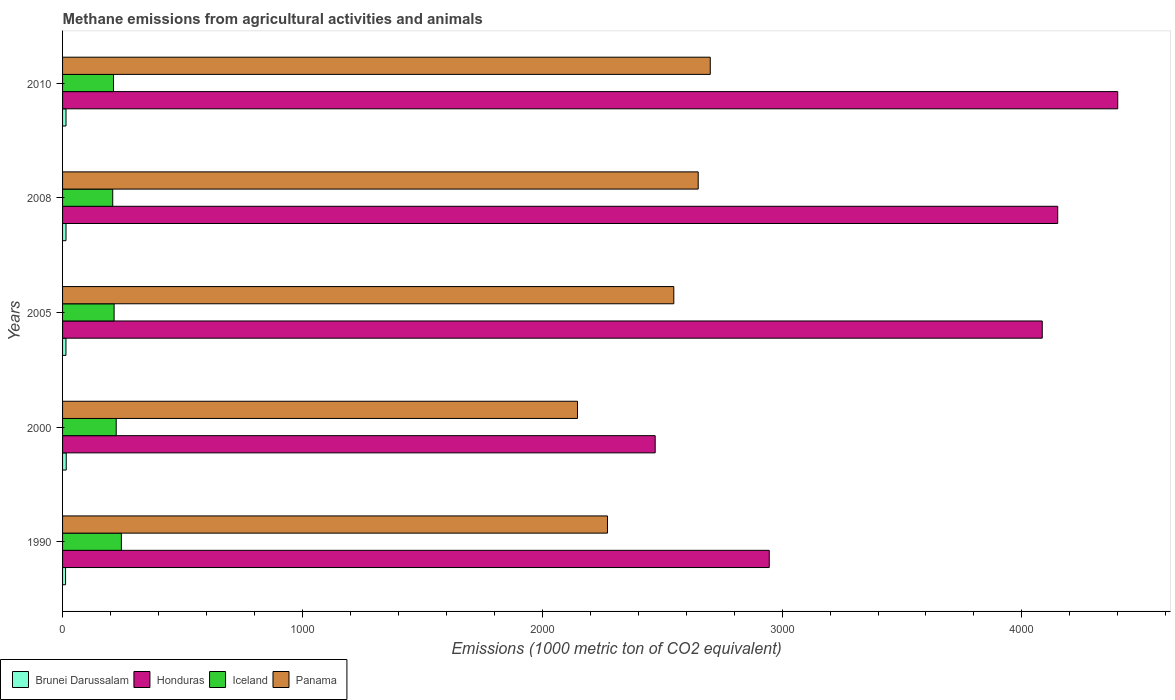How many groups of bars are there?
Ensure brevity in your answer.  5. Are the number of bars per tick equal to the number of legend labels?
Make the answer very short. Yes. Are the number of bars on each tick of the Y-axis equal?
Offer a terse response. Yes. In how many cases, is the number of bars for a given year not equal to the number of legend labels?
Keep it short and to the point. 0. What is the amount of methane emitted in Iceland in 2005?
Ensure brevity in your answer.  214.9. Across all years, what is the maximum amount of methane emitted in Brunei Darussalam?
Ensure brevity in your answer.  15.3. Across all years, what is the minimum amount of methane emitted in Brunei Darussalam?
Ensure brevity in your answer.  12.5. In which year was the amount of methane emitted in Panama maximum?
Offer a terse response. 2010. In which year was the amount of methane emitted in Brunei Darussalam minimum?
Provide a succinct answer. 1990. What is the total amount of methane emitted in Iceland in the graph?
Your answer should be compact. 1105.5. What is the difference between the amount of methane emitted in Iceland in 2008 and that in 2010?
Your answer should be compact. -3.2. What is the difference between the amount of methane emitted in Brunei Darussalam in 1990 and the amount of methane emitted in Iceland in 2005?
Give a very brief answer. -202.4. What is the average amount of methane emitted in Panama per year?
Your answer should be compact. 2463.68. In the year 2008, what is the difference between the amount of methane emitted in Panama and amount of methane emitted in Brunei Darussalam?
Ensure brevity in your answer.  2636. What is the ratio of the amount of methane emitted in Iceland in 2000 to that in 2008?
Your answer should be very brief. 1.07. What is the difference between the highest and the second highest amount of methane emitted in Panama?
Give a very brief answer. 50.3. What is the difference between the highest and the lowest amount of methane emitted in Honduras?
Provide a short and direct response. 1928.6. Is the sum of the amount of methane emitted in Iceland in 2005 and 2008 greater than the maximum amount of methane emitted in Honduras across all years?
Provide a short and direct response. No. What does the 1st bar from the bottom in 2000 represents?
Offer a very short reply. Brunei Darussalam. Is it the case that in every year, the sum of the amount of methane emitted in Panama and amount of methane emitted in Iceland is greater than the amount of methane emitted in Honduras?
Offer a terse response. No. Are all the bars in the graph horizontal?
Ensure brevity in your answer.  Yes. How many years are there in the graph?
Make the answer very short. 5. What is the difference between two consecutive major ticks on the X-axis?
Provide a succinct answer. 1000. Are the values on the major ticks of X-axis written in scientific E-notation?
Your answer should be very brief. No. Does the graph contain any zero values?
Your answer should be compact. No. What is the title of the graph?
Ensure brevity in your answer.  Methane emissions from agricultural activities and animals. Does "Mauritius" appear as one of the legend labels in the graph?
Provide a succinct answer. No. What is the label or title of the X-axis?
Give a very brief answer. Emissions (1000 metric ton of CO2 equivalent). What is the Emissions (1000 metric ton of CO2 equivalent) of Brunei Darussalam in 1990?
Your response must be concise. 12.5. What is the Emissions (1000 metric ton of CO2 equivalent) in Honduras in 1990?
Provide a succinct answer. 2946.5. What is the Emissions (1000 metric ton of CO2 equivalent) of Iceland in 1990?
Your answer should be very brief. 245.3. What is the Emissions (1000 metric ton of CO2 equivalent) of Panama in 1990?
Keep it short and to the point. 2272. What is the Emissions (1000 metric ton of CO2 equivalent) of Honduras in 2000?
Keep it short and to the point. 2470.9. What is the Emissions (1000 metric ton of CO2 equivalent) of Iceland in 2000?
Provide a short and direct response. 223.7. What is the Emissions (1000 metric ton of CO2 equivalent) in Panama in 2000?
Offer a very short reply. 2147. What is the Emissions (1000 metric ton of CO2 equivalent) of Honduras in 2005?
Provide a succinct answer. 4084.8. What is the Emissions (1000 metric ton of CO2 equivalent) of Iceland in 2005?
Offer a very short reply. 214.9. What is the Emissions (1000 metric ton of CO2 equivalent) in Panama in 2005?
Ensure brevity in your answer.  2548.5. What is the Emissions (1000 metric ton of CO2 equivalent) of Honduras in 2008?
Provide a short and direct response. 4149.3. What is the Emissions (1000 metric ton of CO2 equivalent) of Iceland in 2008?
Provide a short and direct response. 209.2. What is the Emissions (1000 metric ton of CO2 equivalent) in Panama in 2008?
Keep it short and to the point. 2650.3. What is the Emissions (1000 metric ton of CO2 equivalent) of Honduras in 2010?
Keep it short and to the point. 4399.5. What is the Emissions (1000 metric ton of CO2 equivalent) in Iceland in 2010?
Provide a short and direct response. 212.4. What is the Emissions (1000 metric ton of CO2 equivalent) of Panama in 2010?
Make the answer very short. 2700.6. Across all years, what is the maximum Emissions (1000 metric ton of CO2 equivalent) of Honduras?
Offer a very short reply. 4399.5. Across all years, what is the maximum Emissions (1000 metric ton of CO2 equivalent) of Iceland?
Offer a terse response. 245.3. Across all years, what is the maximum Emissions (1000 metric ton of CO2 equivalent) in Panama?
Your answer should be very brief. 2700.6. Across all years, what is the minimum Emissions (1000 metric ton of CO2 equivalent) of Honduras?
Keep it short and to the point. 2470.9. Across all years, what is the minimum Emissions (1000 metric ton of CO2 equivalent) in Iceland?
Your answer should be very brief. 209.2. Across all years, what is the minimum Emissions (1000 metric ton of CO2 equivalent) in Panama?
Keep it short and to the point. 2147. What is the total Emissions (1000 metric ton of CO2 equivalent) in Brunei Darussalam in the graph?
Offer a very short reply. 70.6. What is the total Emissions (1000 metric ton of CO2 equivalent) in Honduras in the graph?
Provide a succinct answer. 1.81e+04. What is the total Emissions (1000 metric ton of CO2 equivalent) of Iceland in the graph?
Offer a terse response. 1105.5. What is the total Emissions (1000 metric ton of CO2 equivalent) in Panama in the graph?
Your answer should be compact. 1.23e+04. What is the difference between the Emissions (1000 metric ton of CO2 equivalent) in Brunei Darussalam in 1990 and that in 2000?
Your response must be concise. -2.8. What is the difference between the Emissions (1000 metric ton of CO2 equivalent) of Honduras in 1990 and that in 2000?
Your answer should be compact. 475.6. What is the difference between the Emissions (1000 metric ton of CO2 equivalent) of Iceland in 1990 and that in 2000?
Make the answer very short. 21.6. What is the difference between the Emissions (1000 metric ton of CO2 equivalent) of Panama in 1990 and that in 2000?
Keep it short and to the point. 125. What is the difference between the Emissions (1000 metric ton of CO2 equivalent) of Honduras in 1990 and that in 2005?
Provide a short and direct response. -1138.3. What is the difference between the Emissions (1000 metric ton of CO2 equivalent) in Iceland in 1990 and that in 2005?
Your response must be concise. 30.4. What is the difference between the Emissions (1000 metric ton of CO2 equivalent) of Panama in 1990 and that in 2005?
Give a very brief answer. -276.5. What is the difference between the Emissions (1000 metric ton of CO2 equivalent) of Brunei Darussalam in 1990 and that in 2008?
Offer a very short reply. -1.8. What is the difference between the Emissions (1000 metric ton of CO2 equivalent) in Honduras in 1990 and that in 2008?
Provide a succinct answer. -1202.8. What is the difference between the Emissions (1000 metric ton of CO2 equivalent) in Iceland in 1990 and that in 2008?
Offer a very short reply. 36.1. What is the difference between the Emissions (1000 metric ton of CO2 equivalent) in Panama in 1990 and that in 2008?
Provide a succinct answer. -378.3. What is the difference between the Emissions (1000 metric ton of CO2 equivalent) in Brunei Darussalam in 1990 and that in 2010?
Provide a succinct answer. -1.9. What is the difference between the Emissions (1000 metric ton of CO2 equivalent) of Honduras in 1990 and that in 2010?
Offer a terse response. -1453. What is the difference between the Emissions (1000 metric ton of CO2 equivalent) in Iceland in 1990 and that in 2010?
Your answer should be compact. 32.9. What is the difference between the Emissions (1000 metric ton of CO2 equivalent) in Panama in 1990 and that in 2010?
Make the answer very short. -428.6. What is the difference between the Emissions (1000 metric ton of CO2 equivalent) in Brunei Darussalam in 2000 and that in 2005?
Your answer should be very brief. 1.2. What is the difference between the Emissions (1000 metric ton of CO2 equivalent) in Honduras in 2000 and that in 2005?
Your response must be concise. -1613.9. What is the difference between the Emissions (1000 metric ton of CO2 equivalent) in Iceland in 2000 and that in 2005?
Your answer should be compact. 8.8. What is the difference between the Emissions (1000 metric ton of CO2 equivalent) of Panama in 2000 and that in 2005?
Your response must be concise. -401.5. What is the difference between the Emissions (1000 metric ton of CO2 equivalent) in Honduras in 2000 and that in 2008?
Keep it short and to the point. -1678.4. What is the difference between the Emissions (1000 metric ton of CO2 equivalent) of Iceland in 2000 and that in 2008?
Make the answer very short. 14.5. What is the difference between the Emissions (1000 metric ton of CO2 equivalent) of Panama in 2000 and that in 2008?
Provide a succinct answer. -503.3. What is the difference between the Emissions (1000 metric ton of CO2 equivalent) in Brunei Darussalam in 2000 and that in 2010?
Offer a terse response. 0.9. What is the difference between the Emissions (1000 metric ton of CO2 equivalent) in Honduras in 2000 and that in 2010?
Your response must be concise. -1928.6. What is the difference between the Emissions (1000 metric ton of CO2 equivalent) in Panama in 2000 and that in 2010?
Make the answer very short. -553.6. What is the difference between the Emissions (1000 metric ton of CO2 equivalent) in Honduras in 2005 and that in 2008?
Your answer should be very brief. -64.5. What is the difference between the Emissions (1000 metric ton of CO2 equivalent) in Panama in 2005 and that in 2008?
Ensure brevity in your answer.  -101.8. What is the difference between the Emissions (1000 metric ton of CO2 equivalent) in Brunei Darussalam in 2005 and that in 2010?
Your response must be concise. -0.3. What is the difference between the Emissions (1000 metric ton of CO2 equivalent) in Honduras in 2005 and that in 2010?
Provide a succinct answer. -314.7. What is the difference between the Emissions (1000 metric ton of CO2 equivalent) in Iceland in 2005 and that in 2010?
Your answer should be very brief. 2.5. What is the difference between the Emissions (1000 metric ton of CO2 equivalent) of Panama in 2005 and that in 2010?
Offer a terse response. -152.1. What is the difference between the Emissions (1000 metric ton of CO2 equivalent) in Brunei Darussalam in 2008 and that in 2010?
Ensure brevity in your answer.  -0.1. What is the difference between the Emissions (1000 metric ton of CO2 equivalent) of Honduras in 2008 and that in 2010?
Provide a short and direct response. -250.2. What is the difference between the Emissions (1000 metric ton of CO2 equivalent) of Iceland in 2008 and that in 2010?
Ensure brevity in your answer.  -3.2. What is the difference between the Emissions (1000 metric ton of CO2 equivalent) in Panama in 2008 and that in 2010?
Provide a short and direct response. -50.3. What is the difference between the Emissions (1000 metric ton of CO2 equivalent) of Brunei Darussalam in 1990 and the Emissions (1000 metric ton of CO2 equivalent) of Honduras in 2000?
Offer a very short reply. -2458.4. What is the difference between the Emissions (1000 metric ton of CO2 equivalent) of Brunei Darussalam in 1990 and the Emissions (1000 metric ton of CO2 equivalent) of Iceland in 2000?
Offer a terse response. -211.2. What is the difference between the Emissions (1000 metric ton of CO2 equivalent) in Brunei Darussalam in 1990 and the Emissions (1000 metric ton of CO2 equivalent) in Panama in 2000?
Your response must be concise. -2134.5. What is the difference between the Emissions (1000 metric ton of CO2 equivalent) of Honduras in 1990 and the Emissions (1000 metric ton of CO2 equivalent) of Iceland in 2000?
Your response must be concise. 2722.8. What is the difference between the Emissions (1000 metric ton of CO2 equivalent) of Honduras in 1990 and the Emissions (1000 metric ton of CO2 equivalent) of Panama in 2000?
Provide a succinct answer. 799.5. What is the difference between the Emissions (1000 metric ton of CO2 equivalent) of Iceland in 1990 and the Emissions (1000 metric ton of CO2 equivalent) of Panama in 2000?
Make the answer very short. -1901.7. What is the difference between the Emissions (1000 metric ton of CO2 equivalent) of Brunei Darussalam in 1990 and the Emissions (1000 metric ton of CO2 equivalent) of Honduras in 2005?
Your answer should be very brief. -4072.3. What is the difference between the Emissions (1000 metric ton of CO2 equivalent) of Brunei Darussalam in 1990 and the Emissions (1000 metric ton of CO2 equivalent) of Iceland in 2005?
Your answer should be compact. -202.4. What is the difference between the Emissions (1000 metric ton of CO2 equivalent) of Brunei Darussalam in 1990 and the Emissions (1000 metric ton of CO2 equivalent) of Panama in 2005?
Offer a very short reply. -2536. What is the difference between the Emissions (1000 metric ton of CO2 equivalent) of Honduras in 1990 and the Emissions (1000 metric ton of CO2 equivalent) of Iceland in 2005?
Make the answer very short. 2731.6. What is the difference between the Emissions (1000 metric ton of CO2 equivalent) of Honduras in 1990 and the Emissions (1000 metric ton of CO2 equivalent) of Panama in 2005?
Provide a succinct answer. 398. What is the difference between the Emissions (1000 metric ton of CO2 equivalent) of Iceland in 1990 and the Emissions (1000 metric ton of CO2 equivalent) of Panama in 2005?
Give a very brief answer. -2303.2. What is the difference between the Emissions (1000 metric ton of CO2 equivalent) of Brunei Darussalam in 1990 and the Emissions (1000 metric ton of CO2 equivalent) of Honduras in 2008?
Keep it short and to the point. -4136.8. What is the difference between the Emissions (1000 metric ton of CO2 equivalent) of Brunei Darussalam in 1990 and the Emissions (1000 metric ton of CO2 equivalent) of Iceland in 2008?
Your answer should be compact. -196.7. What is the difference between the Emissions (1000 metric ton of CO2 equivalent) in Brunei Darussalam in 1990 and the Emissions (1000 metric ton of CO2 equivalent) in Panama in 2008?
Provide a succinct answer. -2637.8. What is the difference between the Emissions (1000 metric ton of CO2 equivalent) of Honduras in 1990 and the Emissions (1000 metric ton of CO2 equivalent) of Iceland in 2008?
Your answer should be very brief. 2737.3. What is the difference between the Emissions (1000 metric ton of CO2 equivalent) of Honduras in 1990 and the Emissions (1000 metric ton of CO2 equivalent) of Panama in 2008?
Ensure brevity in your answer.  296.2. What is the difference between the Emissions (1000 metric ton of CO2 equivalent) in Iceland in 1990 and the Emissions (1000 metric ton of CO2 equivalent) in Panama in 2008?
Make the answer very short. -2405. What is the difference between the Emissions (1000 metric ton of CO2 equivalent) of Brunei Darussalam in 1990 and the Emissions (1000 metric ton of CO2 equivalent) of Honduras in 2010?
Keep it short and to the point. -4387. What is the difference between the Emissions (1000 metric ton of CO2 equivalent) in Brunei Darussalam in 1990 and the Emissions (1000 metric ton of CO2 equivalent) in Iceland in 2010?
Your response must be concise. -199.9. What is the difference between the Emissions (1000 metric ton of CO2 equivalent) of Brunei Darussalam in 1990 and the Emissions (1000 metric ton of CO2 equivalent) of Panama in 2010?
Give a very brief answer. -2688.1. What is the difference between the Emissions (1000 metric ton of CO2 equivalent) of Honduras in 1990 and the Emissions (1000 metric ton of CO2 equivalent) of Iceland in 2010?
Give a very brief answer. 2734.1. What is the difference between the Emissions (1000 metric ton of CO2 equivalent) of Honduras in 1990 and the Emissions (1000 metric ton of CO2 equivalent) of Panama in 2010?
Provide a succinct answer. 245.9. What is the difference between the Emissions (1000 metric ton of CO2 equivalent) of Iceland in 1990 and the Emissions (1000 metric ton of CO2 equivalent) of Panama in 2010?
Make the answer very short. -2455.3. What is the difference between the Emissions (1000 metric ton of CO2 equivalent) in Brunei Darussalam in 2000 and the Emissions (1000 metric ton of CO2 equivalent) in Honduras in 2005?
Give a very brief answer. -4069.5. What is the difference between the Emissions (1000 metric ton of CO2 equivalent) of Brunei Darussalam in 2000 and the Emissions (1000 metric ton of CO2 equivalent) of Iceland in 2005?
Provide a short and direct response. -199.6. What is the difference between the Emissions (1000 metric ton of CO2 equivalent) of Brunei Darussalam in 2000 and the Emissions (1000 metric ton of CO2 equivalent) of Panama in 2005?
Offer a terse response. -2533.2. What is the difference between the Emissions (1000 metric ton of CO2 equivalent) of Honduras in 2000 and the Emissions (1000 metric ton of CO2 equivalent) of Iceland in 2005?
Make the answer very short. 2256. What is the difference between the Emissions (1000 metric ton of CO2 equivalent) in Honduras in 2000 and the Emissions (1000 metric ton of CO2 equivalent) in Panama in 2005?
Make the answer very short. -77.6. What is the difference between the Emissions (1000 metric ton of CO2 equivalent) of Iceland in 2000 and the Emissions (1000 metric ton of CO2 equivalent) of Panama in 2005?
Your response must be concise. -2324.8. What is the difference between the Emissions (1000 metric ton of CO2 equivalent) of Brunei Darussalam in 2000 and the Emissions (1000 metric ton of CO2 equivalent) of Honduras in 2008?
Make the answer very short. -4134. What is the difference between the Emissions (1000 metric ton of CO2 equivalent) in Brunei Darussalam in 2000 and the Emissions (1000 metric ton of CO2 equivalent) in Iceland in 2008?
Offer a terse response. -193.9. What is the difference between the Emissions (1000 metric ton of CO2 equivalent) of Brunei Darussalam in 2000 and the Emissions (1000 metric ton of CO2 equivalent) of Panama in 2008?
Offer a very short reply. -2635. What is the difference between the Emissions (1000 metric ton of CO2 equivalent) in Honduras in 2000 and the Emissions (1000 metric ton of CO2 equivalent) in Iceland in 2008?
Keep it short and to the point. 2261.7. What is the difference between the Emissions (1000 metric ton of CO2 equivalent) of Honduras in 2000 and the Emissions (1000 metric ton of CO2 equivalent) of Panama in 2008?
Your answer should be very brief. -179.4. What is the difference between the Emissions (1000 metric ton of CO2 equivalent) in Iceland in 2000 and the Emissions (1000 metric ton of CO2 equivalent) in Panama in 2008?
Your answer should be very brief. -2426.6. What is the difference between the Emissions (1000 metric ton of CO2 equivalent) in Brunei Darussalam in 2000 and the Emissions (1000 metric ton of CO2 equivalent) in Honduras in 2010?
Offer a terse response. -4384.2. What is the difference between the Emissions (1000 metric ton of CO2 equivalent) in Brunei Darussalam in 2000 and the Emissions (1000 metric ton of CO2 equivalent) in Iceland in 2010?
Your answer should be very brief. -197.1. What is the difference between the Emissions (1000 metric ton of CO2 equivalent) in Brunei Darussalam in 2000 and the Emissions (1000 metric ton of CO2 equivalent) in Panama in 2010?
Ensure brevity in your answer.  -2685.3. What is the difference between the Emissions (1000 metric ton of CO2 equivalent) of Honduras in 2000 and the Emissions (1000 metric ton of CO2 equivalent) of Iceland in 2010?
Ensure brevity in your answer.  2258.5. What is the difference between the Emissions (1000 metric ton of CO2 equivalent) in Honduras in 2000 and the Emissions (1000 metric ton of CO2 equivalent) in Panama in 2010?
Ensure brevity in your answer.  -229.7. What is the difference between the Emissions (1000 metric ton of CO2 equivalent) of Iceland in 2000 and the Emissions (1000 metric ton of CO2 equivalent) of Panama in 2010?
Make the answer very short. -2476.9. What is the difference between the Emissions (1000 metric ton of CO2 equivalent) of Brunei Darussalam in 2005 and the Emissions (1000 metric ton of CO2 equivalent) of Honduras in 2008?
Give a very brief answer. -4135.2. What is the difference between the Emissions (1000 metric ton of CO2 equivalent) of Brunei Darussalam in 2005 and the Emissions (1000 metric ton of CO2 equivalent) of Iceland in 2008?
Provide a succinct answer. -195.1. What is the difference between the Emissions (1000 metric ton of CO2 equivalent) in Brunei Darussalam in 2005 and the Emissions (1000 metric ton of CO2 equivalent) in Panama in 2008?
Provide a short and direct response. -2636.2. What is the difference between the Emissions (1000 metric ton of CO2 equivalent) in Honduras in 2005 and the Emissions (1000 metric ton of CO2 equivalent) in Iceland in 2008?
Make the answer very short. 3875.6. What is the difference between the Emissions (1000 metric ton of CO2 equivalent) in Honduras in 2005 and the Emissions (1000 metric ton of CO2 equivalent) in Panama in 2008?
Provide a succinct answer. 1434.5. What is the difference between the Emissions (1000 metric ton of CO2 equivalent) in Iceland in 2005 and the Emissions (1000 metric ton of CO2 equivalent) in Panama in 2008?
Your response must be concise. -2435.4. What is the difference between the Emissions (1000 metric ton of CO2 equivalent) of Brunei Darussalam in 2005 and the Emissions (1000 metric ton of CO2 equivalent) of Honduras in 2010?
Ensure brevity in your answer.  -4385.4. What is the difference between the Emissions (1000 metric ton of CO2 equivalent) in Brunei Darussalam in 2005 and the Emissions (1000 metric ton of CO2 equivalent) in Iceland in 2010?
Offer a very short reply. -198.3. What is the difference between the Emissions (1000 metric ton of CO2 equivalent) in Brunei Darussalam in 2005 and the Emissions (1000 metric ton of CO2 equivalent) in Panama in 2010?
Provide a succinct answer. -2686.5. What is the difference between the Emissions (1000 metric ton of CO2 equivalent) of Honduras in 2005 and the Emissions (1000 metric ton of CO2 equivalent) of Iceland in 2010?
Give a very brief answer. 3872.4. What is the difference between the Emissions (1000 metric ton of CO2 equivalent) in Honduras in 2005 and the Emissions (1000 metric ton of CO2 equivalent) in Panama in 2010?
Provide a short and direct response. 1384.2. What is the difference between the Emissions (1000 metric ton of CO2 equivalent) of Iceland in 2005 and the Emissions (1000 metric ton of CO2 equivalent) of Panama in 2010?
Ensure brevity in your answer.  -2485.7. What is the difference between the Emissions (1000 metric ton of CO2 equivalent) of Brunei Darussalam in 2008 and the Emissions (1000 metric ton of CO2 equivalent) of Honduras in 2010?
Provide a short and direct response. -4385.2. What is the difference between the Emissions (1000 metric ton of CO2 equivalent) in Brunei Darussalam in 2008 and the Emissions (1000 metric ton of CO2 equivalent) in Iceland in 2010?
Offer a terse response. -198.1. What is the difference between the Emissions (1000 metric ton of CO2 equivalent) in Brunei Darussalam in 2008 and the Emissions (1000 metric ton of CO2 equivalent) in Panama in 2010?
Ensure brevity in your answer.  -2686.3. What is the difference between the Emissions (1000 metric ton of CO2 equivalent) of Honduras in 2008 and the Emissions (1000 metric ton of CO2 equivalent) of Iceland in 2010?
Provide a short and direct response. 3936.9. What is the difference between the Emissions (1000 metric ton of CO2 equivalent) of Honduras in 2008 and the Emissions (1000 metric ton of CO2 equivalent) of Panama in 2010?
Your answer should be very brief. 1448.7. What is the difference between the Emissions (1000 metric ton of CO2 equivalent) in Iceland in 2008 and the Emissions (1000 metric ton of CO2 equivalent) in Panama in 2010?
Provide a short and direct response. -2491.4. What is the average Emissions (1000 metric ton of CO2 equivalent) in Brunei Darussalam per year?
Your response must be concise. 14.12. What is the average Emissions (1000 metric ton of CO2 equivalent) in Honduras per year?
Provide a succinct answer. 3610.2. What is the average Emissions (1000 metric ton of CO2 equivalent) of Iceland per year?
Provide a short and direct response. 221.1. What is the average Emissions (1000 metric ton of CO2 equivalent) of Panama per year?
Your answer should be compact. 2463.68. In the year 1990, what is the difference between the Emissions (1000 metric ton of CO2 equivalent) in Brunei Darussalam and Emissions (1000 metric ton of CO2 equivalent) in Honduras?
Your response must be concise. -2934. In the year 1990, what is the difference between the Emissions (1000 metric ton of CO2 equivalent) of Brunei Darussalam and Emissions (1000 metric ton of CO2 equivalent) of Iceland?
Your answer should be compact. -232.8. In the year 1990, what is the difference between the Emissions (1000 metric ton of CO2 equivalent) of Brunei Darussalam and Emissions (1000 metric ton of CO2 equivalent) of Panama?
Keep it short and to the point. -2259.5. In the year 1990, what is the difference between the Emissions (1000 metric ton of CO2 equivalent) in Honduras and Emissions (1000 metric ton of CO2 equivalent) in Iceland?
Offer a terse response. 2701.2. In the year 1990, what is the difference between the Emissions (1000 metric ton of CO2 equivalent) of Honduras and Emissions (1000 metric ton of CO2 equivalent) of Panama?
Make the answer very short. 674.5. In the year 1990, what is the difference between the Emissions (1000 metric ton of CO2 equivalent) in Iceland and Emissions (1000 metric ton of CO2 equivalent) in Panama?
Offer a very short reply. -2026.7. In the year 2000, what is the difference between the Emissions (1000 metric ton of CO2 equivalent) in Brunei Darussalam and Emissions (1000 metric ton of CO2 equivalent) in Honduras?
Your answer should be very brief. -2455.6. In the year 2000, what is the difference between the Emissions (1000 metric ton of CO2 equivalent) in Brunei Darussalam and Emissions (1000 metric ton of CO2 equivalent) in Iceland?
Offer a terse response. -208.4. In the year 2000, what is the difference between the Emissions (1000 metric ton of CO2 equivalent) of Brunei Darussalam and Emissions (1000 metric ton of CO2 equivalent) of Panama?
Offer a terse response. -2131.7. In the year 2000, what is the difference between the Emissions (1000 metric ton of CO2 equivalent) of Honduras and Emissions (1000 metric ton of CO2 equivalent) of Iceland?
Offer a very short reply. 2247.2. In the year 2000, what is the difference between the Emissions (1000 metric ton of CO2 equivalent) in Honduras and Emissions (1000 metric ton of CO2 equivalent) in Panama?
Provide a short and direct response. 323.9. In the year 2000, what is the difference between the Emissions (1000 metric ton of CO2 equivalent) of Iceland and Emissions (1000 metric ton of CO2 equivalent) of Panama?
Provide a short and direct response. -1923.3. In the year 2005, what is the difference between the Emissions (1000 metric ton of CO2 equivalent) in Brunei Darussalam and Emissions (1000 metric ton of CO2 equivalent) in Honduras?
Your answer should be very brief. -4070.7. In the year 2005, what is the difference between the Emissions (1000 metric ton of CO2 equivalent) of Brunei Darussalam and Emissions (1000 metric ton of CO2 equivalent) of Iceland?
Your answer should be very brief. -200.8. In the year 2005, what is the difference between the Emissions (1000 metric ton of CO2 equivalent) in Brunei Darussalam and Emissions (1000 metric ton of CO2 equivalent) in Panama?
Your response must be concise. -2534.4. In the year 2005, what is the difference between the Emissions (1000 metric ton of CO2 equivalent) in Honduras and Emissions (1000 metric ton of CO2 equivalent) in Iceland?
Ensure brevity in your answer.  3869.9. In the year 2005, what is the difference between the Emissions (1000 metric ton of CO2 equivalent) in Honduras and Emissions (1000 metric ton of CO2 equivalent) in Panama?
Give a very brief answer. 1536.3. In the year 2005, what is the difference between the Emissions (1000 metric ton of CO2 equivalent) in Iceland and Emissions (1000 metric ton of CO2 equivalent) in Panama?
Your response must be concise. -2333.6. In the year 2008, what is the difference between the Emissions (1000 metric ton of CO2 equivalent) of Brunei Darussalam and Emissions (1000 metric ton of CO2 equivalent) of Honduras?
Your answer should be compact. -4135. In the year 2008, what is the difference between the Emissions (1000 metric ton of CO2 equivalent) of Brunei Darussalam and Emissions (1000 metric ton of CO2 equivalent) of Iceland?
Keep it short and to the point. -194.9. In the year 2008, what is the difference between the Emissions (1000 metric ton of CO2 equivalent) in Brunei Darussalam and Emissions (1000 metric ton of CO2 equivalent) in Panama?
Your answer should be very brief. -2636. In the year 2008, what is the difference between the Emissions (1000 metric ton of CO2 equivalent) of Honduras and Emissions (1000 metric ton of CO2 equivalent) of Iceland?
Ensure brevity in your answer.  3940.1. In the year 2008, what is the difference between the Emissions (1000 metric ton of CO2 equivalent) in Honduras and Emissions (1000 metric ton of CO2 equivalent) in Panama?
Make the answer very short. 1499. In the year 2008, what is the difference between the Emissions (1000 metric ton of CO2 equivalent) in Iceland and Emissions (1000 metric ton of CO2 equivalent) in Panama?
Offer a very short reply. -2441.1. In the year 2010, what is the difference between the Emissions (1000 metric ton of CO2 equivalent) in Brunei Darussalam and Emissions (1000 metric ton of CO2 equivalent) in Honduras?
Your answer should be very brief. -4385.1. In the year 2010, what is the difference between the Emissions (1000 metric ton of CO2 equivalent) in Brunei Darussalam and Emissions (1000 metric ton of CO2 equivalent) in Iceland?
Keep it short and to the point. -198. In the year 2010, what is the difference between the Emissions (1000 metric ton of CO2 equivalent) in Brunei Darussalam and Emissions (1000 metric ton of CO2 equivalent) in Panama?
Your answer should be very brief. -2686.2. In the year 2010, what is the difference between the Emissions (1000 metric ton of CO2 equivalent) of Honduras and Emissions (1000 metric ton of CO2 equivalent) of Iceland?
Provide a short and direct response. 4187.1. In the year 2010, what is the difference between the Emissions (1000 metric ton of CO2 equivalent) of Honduras and Emissions (1000 metric ton of CO2 equivalent) of Panama?
Ensure brevity in your answer.  1698.9. In the year 2010, what is the difference between the Emissions (1000 metric ton of CO2 equivalent) in Iceland and Emissions (1000 metric ton of CO2 equivalent) in Panama?
Keep it short and to the point. -2488.2. What is the ratio of the Emissions (1000 metric ton of CO2 equivalent) of Brunei Darussalam in 1990 to that in 2000?
Keep it short and to the point. 0.82. What is the ratio of the Emissions (1000 metric ton of CO2 equivalent) in Honduras in 1990 to that in 2000?
Provide a succinct answer. 1.19. What is the ratio of the Emissions (1000 metric ton of CO2 equivalent) of Iceland in 1990 to that in 2000?
Provide a succinct answer. 1.1. What is the ratio of the Emissions (1000 metric ton of CO2 equivalent) in Panama in 1990 to that in 2000?
Keep it short and to the point. 1.06. What is the ratio of the Emissions (1000 metric ton of CO2 equivalent) in Brunei Darussalam in 1990 to that in 2005?
Ensure brevity in your answer.  0.89. What is the ratio of the Emissions (1000 metric ton of CO2 equivalent) in Honduras in 1990 to that in 2005?
Give a very brief answer. 0.72. What is the ratio of the Emissions (1000 metric ton of CO2 equivalent) in Iceland in 1990 to that in 2005?
Offer a terse response. 1.14. What is the ratio of the Emissions (1000 metric ton of CO2 equivalent) in Panama in 1990 to that in 2005?
Your answer should be very brief. 0.89. What is the ratio of the Emissions (1000 metric ton of CO2 equivalent) of Brunei Darussalam in 1990 to that in 2008?
Your answer should be compact. 0.87. What is the ratio of the Emissions (1000 metric ton of CO2 equivalent) in Honduras in 1990 to that in 2008?
Your response must be concise. 0.71. What is the ratio of the Emissions (1000 metric ton of CO2 equivalent) of Iceland in 1990 to that in 2008?
Provide a succinct answer. 1.17. What is the ratio of the Emissions (1000 metric ton of CO2 equivalent) in Panama in 1990 to that in 2008?
Your response must be concise. 0.86. What is the ratio of the Emissions (1000 metric ton of CO2 equivalent) in Brunei Darussalam in 1990 to that in 2010?
Give a very brief answer. 0.87. What is the ratio of the Emissions (1000 metric ton of CO2 equivalent) of Honduras in 1990 to that in 2010?
Offer a very short reply. 0.67. What is the ratio of the Emissions (1000 metric ton of CO2 equivalent) of Iceland in 1990 to that in 2010?
Your answer should be compact. 1.15. What is the ratio of the Emissions (1000 metric ton of CO2 equivalent) of Panama in 1990 to that in 2010?
Offer a very short reply. 0.84. What is the ratio of the Emissions (1000 metric ton of CO2 equivalent) in Brunei Darussalam in 2000 to that in 2005?
Provide a succinct answer. 1.09. What is the ratio of the Emissions (1000 metric ton of CO2 equivalent) of Honduras in 2000 to that in 2005?
Make the answer very short. 0.6. What is the ratio of the Emissions (1000 metric ton of CO2 equivalent) of Iceland in 2000 to that in 2005?
Provide a short and direct response. 1.04. What is the ratio of the Emissions (1000 metric ton of CO2 equivalent) in Panama in 2000 to that in 2005?
Keep it short and to the point. 0.84. What is the ratio of the Emissions (1000 metric ton of CO2 equivalent) of Brunei Darussalam in 2000 to that in 2008?
Offer a terse response. 1.07. What is the ratio of the Emissions (1000 metric ton of CO2 equivalent) in Honduras in 2000 to that in 2008?
Your response must be concise. 0.6. What is the ratio of the Emissions (1000 metric ton of CO2 equivalent) in Iceland in 2000 to that in 2008?
Offer a very short reply. 1.07. What is the ratio of the Emissions (1000 metric ton of CO2 equivalent) in Panama in 2000 to that in 2008?
Make the answer very short. 0.81. What is the ratio of the Emissions (1000 metric ton of CO2 equivalent) in Honduras in 2000 to that in 2010?
Make the answer very short. 0.56. What is the ratio of the Emissions (1000 metric ton of CO2 equivalent) in Iceland in 2000 to that in 2010?
Ensure brevity in your answer.  1.05. What is the ratio of the Emissions (1000 metric ton of CO2 equivalent) in Panama in 2000 to that in 2010?
Give a very brief answer. 0.8. What is the ratio of the Emissions (1000 metric ton of CO2 equivalent) of Honduras in 2005 to that in 2008?
Your response must be concise. 0.98. What is the ratio of the Emissions (1000 metric ton of CO2 equivalent) of Iceland in 2005 to that in 2008?
Ensure brevity in your answer.  1.03. What is the ratio of the Emissions (1000 metric ton of CO2 equivalent) in Panama in 2005 to that in 2008?
Provide a short and direct response. 0.96. What is the ratio of the Emissions (1000 metric ton of CO2 equivalent) in Brunei Darussalam in 2005 to that in 2010?
Your answer should be compact. 0.98. What is the ratio of the Emissions (1000 metric ton of CO2 equivalent) of Honduras in 2005 to that in 2010?
Make the answer very short. 0.93. What is the ratio of the Emissions (1000 metric ton of CO2 equivalent) of Iceland in 2005 to that in 2010?
Make the answer very short. 1.01. What is the ratio of the Emissions (1000 metric ton of CO2 equivalent) of Panama in 2005 to that in 2010?
Offer a terse response. 0.94. What is the ratio of the Emissions (1000 metric ton of CO2 equivalent) of Brunei Darussalam in 2008 to that in 2010?
Your answer should be very brief. 0.99. What is the ratio of the Emissions (1000 metric ton of CO2 equivalent) in Honduras in 2008 to that in 2010?
Your answer should be compact. 0.94. What is the ratio of the Emissions (1000 metric ton of CO2 equivalent) of Iceland in 2008 to that in 2010?
Provide a short and direct response. 0.98. What is the ratio of the Emissions (1000 metric ton of CO2 equivalent) in Panama in 2008 to that in 2010?
Your answer should be compact. 0.98. What is the difference between the highest and the second highest Emissions (1000 metric ton of CO2 equivalent) in Honduras?
Your response must be concise. 250.2. What is the difference between the highest and the second highest Emissions (1000 metric ton of CO2 equivalent) in Iceland?
Your answer should be compact. 21.6. What is the difference between the highest and the second highest Emissions (1000 metric ton of CO2 equivalent) in Panama?
Your answer should be compact. 50.3. What is the difference between the highest and the lowest Emissions (1000 metric ton of CO2 equivalent) of Brunei Darussalam?
Keep it short and to the point. 2.8. What is the difference between the highest and the lowest Emissions (1000 metric ton of CO2 equivalent) in Honduras?
Your answer should be very brief. 1928.6. What is the difference between the highest and the lowest Emissions (1000 metric ton of CO2 equivalent) in Iceland?
Make the answer very short. 36.1. What is the difference between the highest and the lowest Emissions (1000 metric ton of CO2 equivalent) in Panama?
Your answer should be very brief. 553.6. 